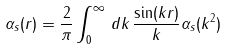<formula> <loc_0><loc_0><loc_500><loc_500>\alpha _ { s } ( r ) = \frac { 2 } { \pi } \int _ { 0 } ^ { \infty } \, d k \, \frac { \sin ( k r ) } { k } \alpha _ { s } ( k ^ { 2 } )</formula> 